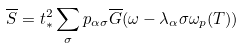<formula> <loc_0><loc_0><loc_500><loc_500>\overline { S } = t _ { * } ^ { 2 } \sum _ { \sigma } p _ { \alpha \sigma } \overline { G } ( \omega - \lambda _ { \alpha } \sigma \omega _ { p } ( T ) )</formula> 